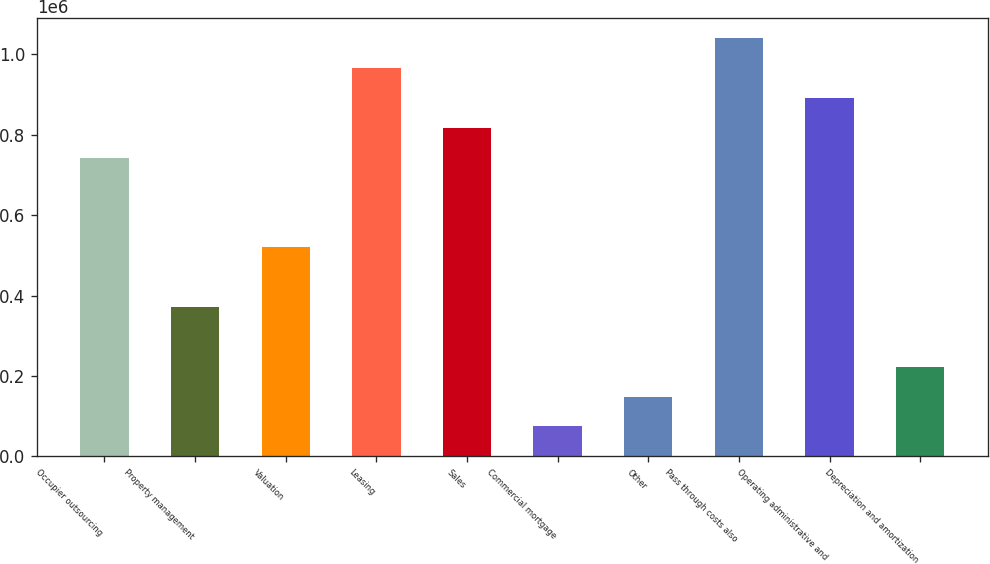<chart> <loc_0><loc_0><loc_500><loc_500><bar_chart><fcel>Occupier outsourcing<fcel>Property management<fcel>Valuation<fcel>Leasing<fcel>Sales<fcel>Commercial mortgage<fcel>Other<fcel>Pass through costs also<fcel>Operating administrative and<fcel>Depreciation and amortization<nl><fcel>742728<fcel>371476<fcel>519976<fcel>965480<fcel>816978<fcel>74473.5<fcel>148724<fcel>1.03973e+06<fcel>891229<fcel>222974<nl></chart> 